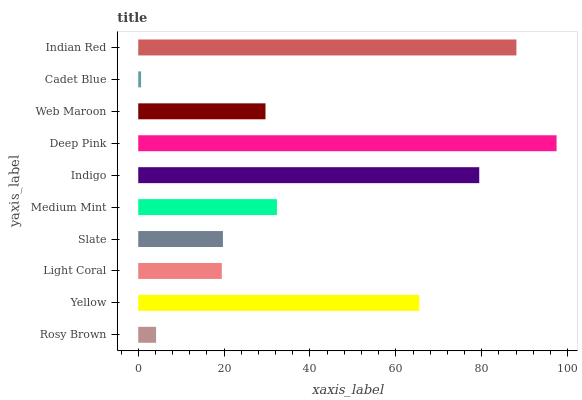Is Cadet Blue the minimum?
Answer yes or no. Yes. Is Deep Pink the maximum?
Answer yes or no. Yes. Is Yellow the minimum?
Answer yes or no. No. Is Yellow the maximum?
Answer yes or no. No. Is Yellow greater than Rosy Brown?
Answer yes or no. Yes. Is Rosy Brown less than Yellow?
Answer yes or no. Yes. Is Rosy Brown greater than Yellow?
Answer yes or no. No. Is Yellow less than Rosy Brown?
Answer yes or no. No. Is Medium Mint the high median?
Answer yes or no. Yes. Is Web Maroon the low median?
Answer yes or no. Yes. Is Yellow the high median?
Answer yes or no. No. Is Deep Pink the low median?
Answer yes or no. No. 